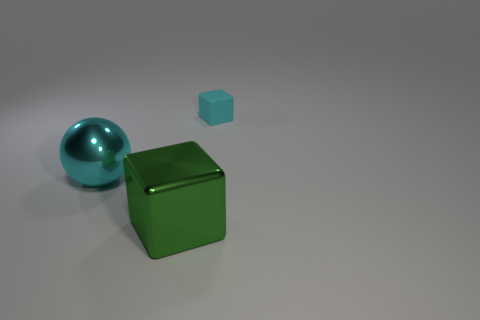The small object that is the same color as the large sphere is what shape?
Offer a very short reply. Cube. Is the number of cyan shiny balls greater than the number of large gray metal balls?
Give a very brief answer. Yes. There is a object on the left side of the cube on the left side of the object that is right of the big green metallic thing; what color is it?
Make the answer very short. Cyan. Does the cyan thing in front of the matte thing have the same shape as the tiny rubber thing?
Provide a succinct answer. No. What color is the shiny sphere that is the same size as the shiny block?
Make the answer very short. Cyan. How many big matte blocks are there?
Your response must be concise. 0. Is the cube that is to the right of the green block made of the same material as the green block?
Ensure brevity in your answer.  No. There is a object that is both in front of the small cyan thing and on the right side of the large cyan sphere; what is it made of?
Ensure brevity in your answer.  Metal. There is a rubber block that is the same color as the shiny sphere; what size is it?
Your response must be concise. Small. There is a cyan object that is in front of the block that is behind the big shiny block; what is its material?
Give a very brief answer. Metal. 